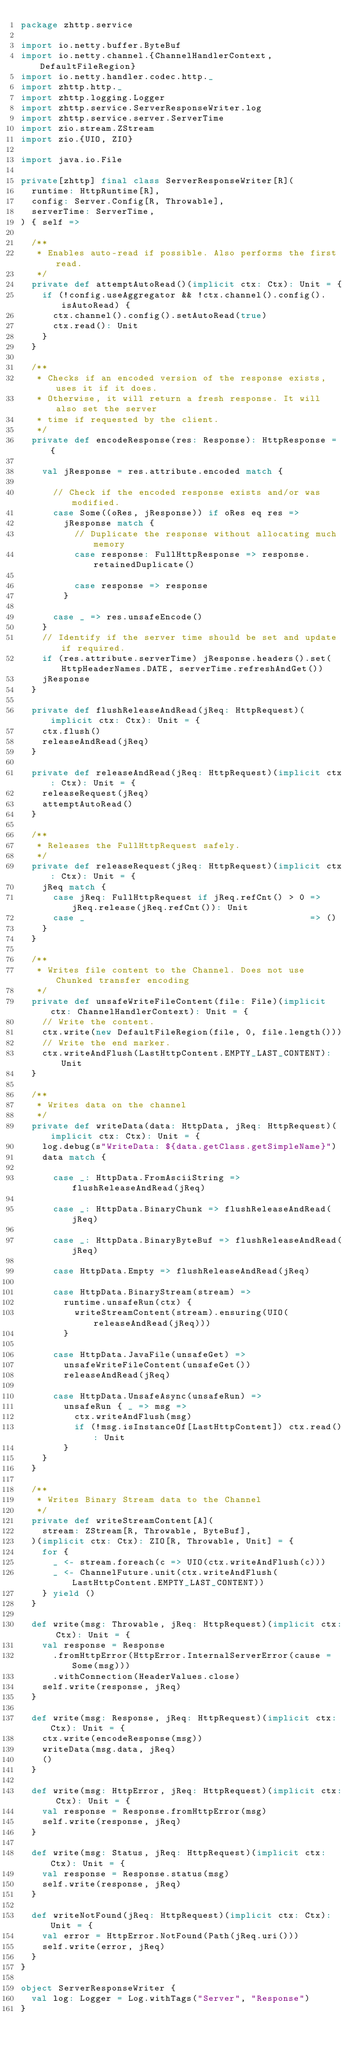<code> <loc_0><loc_0><loc_500><loc_500><_Scala_>package zhttp.service

import io.netty.buffer.ByteBuf
import io.netty.channel.{ChannelHandlerContext, DefaultFileRegion}
import io.netty.handler.codec.http._
import zhttp.http._
import zhttp.logging.Logger
import zhttp.service.ServerResponseWriter.log
import zhttp.service.server.ServerTime
import zio.stream.ZStream
import zio.{UIO, ZIO}

import java.io.File

private[zhttp] final class ServerResponseWriter[R](
  runtime: HttpRuntime[R],
  config: Server.Config[R, Throwable],
  serverTime: ServerTime,
) { self =>

  /**
   * Enables auto-read if possible. Also performs the first read.
   */
  private def attemptAutoRead()(implicit ctx: Ctx): Unit = {
    if (!config.useAggregator && !ctx.channel().config().isAutoRead) {
      ctx.channel().config().setAutoRead(true)
      ctx.read(): Unit
    }
  }

  /**
   * Checks if an encoded version of the response exists, uses it if it does.
   * Otherwise, it will return a fresh response. It will also set the server
   * time if requested by the client.
   */
  private def encodeResponse(res: Response): HttpResponse = {

    val jResponse = res.attribute.encoded match {

      // Check if the encoded response exists and/or was modified.
      case Some((oRes, jResponse)) if oRes eq res =>
        jResponse match {
          // Duplicate the response without allocating much memory
          case response: FullHttpResponse => response.retainedDuplicate()

          case response => response
        }

      case _ => res.unsafeEncode()
    }
    // Identify if the server time should be set and update if required.
    if (res.attribute.serverTime) jResponse.headers().set(HttpHeaderNames.DATE, serverTime.refreshAndGet())
    jResponse
  }

  private def flushReleaseAndRead(jReq: HttpRequest)(implicit ctx: Ctx): Unit = {
    ctx.flush()
    releaseAndRead(jReq)
  }

  private def releaseAndRead(jReq: HttpRequest)(implicit ctx: Ctx): Unit = {
    releaseRequest(jReq)
    attemptAutoRead()
  }

  /**
   * Releases the FullHttpRequest safely.
   */
  private def releaseRequest(jReq: HttpRequest)(implicit ctx: Ctx): Unit = {
    jReq match {
      case jReq: FullHttpRequest if jReq.refCnt() > 0 => jReq.release(jReq.refCnt()): Unit
      case _                                          => ()
    }
  }

  /**
   * Writes file content to the Channel. Does not use Chunked transfer encoding
   */
  private def unsafeWriteFileContent(file: File)(implicit ctx: ChannelHandlerContext): Unit = {
    // Write the content.
    ctx.write(new DefaultFileRegion(file, 0, file.length()))
    // Write the end marker.
    ctx.writeAndFlush(LastHttpContent.EMPTY_LAST_CONTENT): Unit
  }

  /**
   * Writes data on the channel
   */
  private def writeData(data: HttpData, jReq: HttpRequest)(implicit ctx: Ctx): Unit = {
    log.debug(s"WriteData: ${data.getClass.getSimpleName}")
    data match {

      case _: HttpData.FromAsciiString => flushReleaseAndRead(jReq)

      case _: HttpData.BinaryChunk => flushReleaseAndRead(jReq)

      case _: HttpData.BinaryByteBuf => flushReleaseAndRead(jReq)

      case HttpData.Empty => flushReleaseAndRead(jReq)

      case HttpData.BinaryStream(stream) =>
        runtime.unsafeRun(ctx) {
          writeStreamContent(stream).ensuring(UIO(releaseAndRead(jReq)))
        }

      case HttpData.JavaFile(unsafeGet) =>
        unsafeWriteFileContent(unsafeGet())
        releaseAndRead(jReq)

      case HttpData.UnsafeAsync(unsafeRun) =>
        unsafeRun { _ => msg =>
          ctx.writeAndFlush(msg)
          if (!msg.isInstanceOf[LastHttpContent]) ctx.read(): Unit
        }
    }
  }

  /**
   * Writes Binary Stream data to the Channel
   */
  private def writeStreamContent[A](
    stream: ZStream[R, Throwable, ByteBuf],
  )(implicit ctx: Ctx): ZIO[R, Throwable, Unit] = {
    for {
      _ <- stream.foreach(c => UIO(ctx.writeAndFlush(c)))
      _ <- ChannelFuture.unit(ctx.writeAndFlush(LastHttpContent.EMPTY_LAST_CONTENT))
    } yield ()
  }

  def write(msg: Throwable, jReq: HttpRequest)(implicit ctx: Ctx): Unit = {
    val response = Response
      .fromHttpError(HttpError.InternalServerError(cause = Some(msg)))
      .withConnection(HeaderValues.close)
    self.write(response, jReq)
  }

  def write(msg: Response, jReq: HttpRequest)(implicit ctx: Ctx): Unit = {
    ctx.write(encodeResponse(msg))
    writeData(msg.data, jReq)
    ()
  }

  def write(msg: HttpError, jReq: HttpRequest)(implicit ctx: Ctx): Unit = {
    val response = Response.fromHttpError(msg)
    self.write(response, jReq)
  }

  def write(msg: Status, jReq: HttpRequest)(implicit ctx: Ctx): Unit = {
    val response = Response.status(msg)
    self.write(response, jReq)
  }

  def writeNotFound(jReq: HttpRequest)(implicit ctx: Ctx): Unit = {
    val error = HttpError.NotFound(Path(jReq.uri()))
    self.write(error, jReq)
  }
}

object ServerResponseWriter {
  val log: Logger = Log.withTags("Server", "Response")
}
</code> 